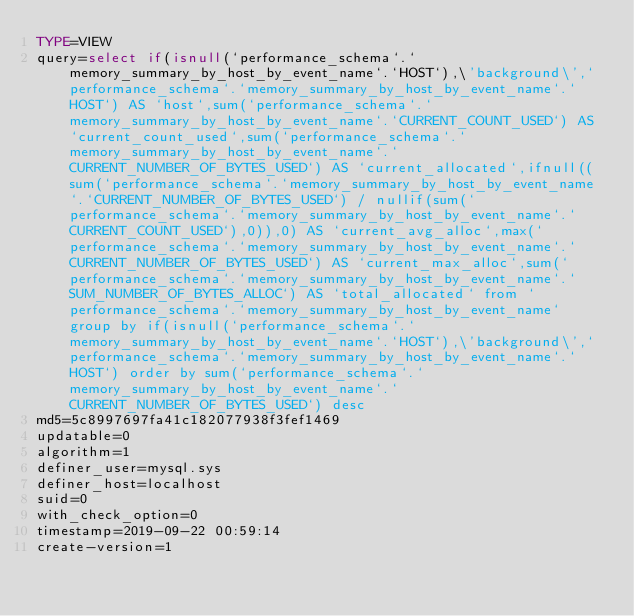<code> <loc_0><loc_0><loc_500><loc_500><_VisualBasic_>TYPE=VIEW
query=select if(isnull(`performance_schema`.`memory_summary_by_host_by_event_name`.`HOST`),\'background\',`performance_schema`.`memory_summary_by_host_by_event_name`.`HOST`) AS `host`,sum(`performance_schema`.`memory_summary_by_host_by_event_name`.`CURRENT_COUNT_USED`) AS `current_count_used`,sum(`performance_schema`.`memory_summary_by_host_by_event_name`.`CURRENT_NUMBER_OF_BYTES_USED`) AS `current_allocated`,ifnull((sum(`performance_schema`.`memory_summary_by_host_by_event_name`.`CURRENT_NUMBER_OF_BYTES_USED`) / nullif(sum(`performance_schema`.`memory_summary_by_host_by_event_name`.`CURRENT_COUNT_USED`),0)),0) AS `current_avg_alloc`,max(`performance_schema`.`memory_summary_by_host_by_event_name`.`CURRENT_NUMBER_OF_BYTES_USED`) AS `current_max_alloc`,sum(`performance_schema`.`memory_summary_by_host_by_event_name`.`SUM_NUMBER_OF_BYTES_ALLOC`) AS `total_allocated` from `performance_schema`.`memory_summary_by_host_by_event_name` group by if(isnull(`performance_schema`.`memory_summary_by_host_by_event_name`.`HOST`),\'background\',`performance_schema`.`memory_summary_by_host_by_event_name`.`HOST`) order by sum(`performance_schema`.`memory_summary_by_host_by_event_name`.`CURRENT_NUMBER_OF_BYTES_USED`) desc
md5=5c8997697fa41c182077938f3fef1469
updatable=0
algorithm=1
definer_user=mysql.sys
definer_host=localhost
suid=0
with_check_option=0
timestamp=2019-09-22 00:59:14
create-version=1</code> 